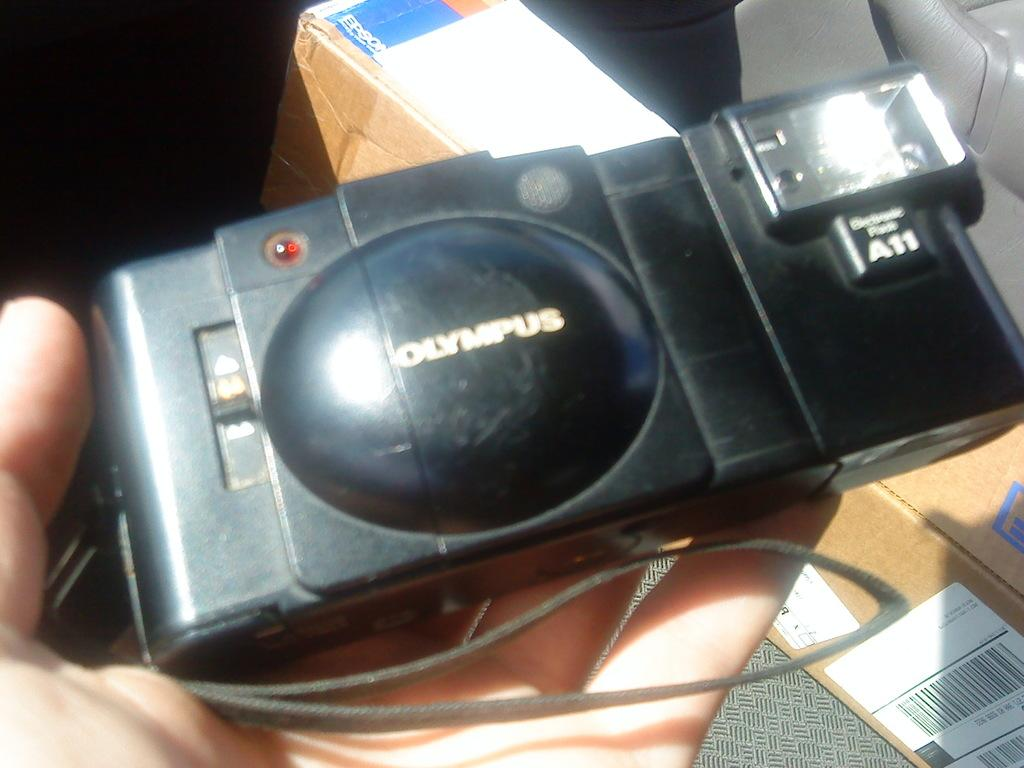What is the person's hand doing in the image? The hand is holding a camera in the image. What object is the person using to capture images? The person is using a camera to capture images. What can be seen in the background of the image? There is a cardboard box in the background of the image. What type of cover is being used to protect the house in the image? There is no house or cover present in the image; it only features a person's hand holding a camera and a cardboard box in the background. 